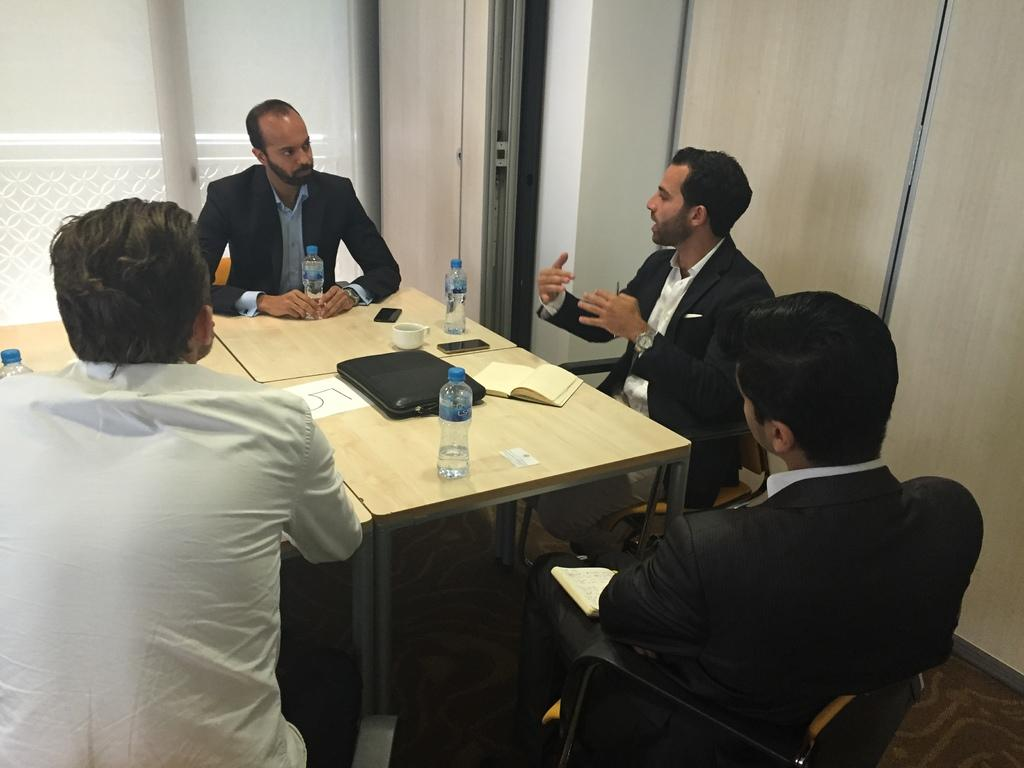How many people are in the room? There are four people in the room. What are the people doing in the room? The people are sitting and talking to each other. What is in the center of the room? There is a table in the center of the room. What items can be found on the table? There are bottles, a cup, food, and a book on the table. What type of pickle is the father holding in the image? There is no father or pickle present in the image. How many thumbs does the person on the left have in the image? We cannot determine the number of thumbs the people have in the image, as it is not visible or mentioned in the provided facts. 